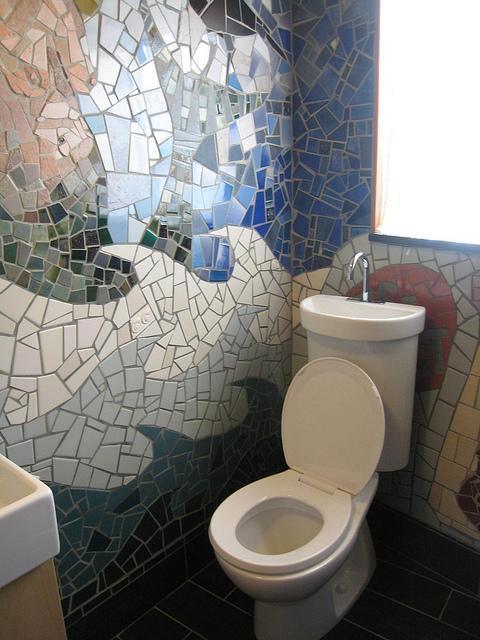How many sinks are there?
Give a very brief answer. 2. 